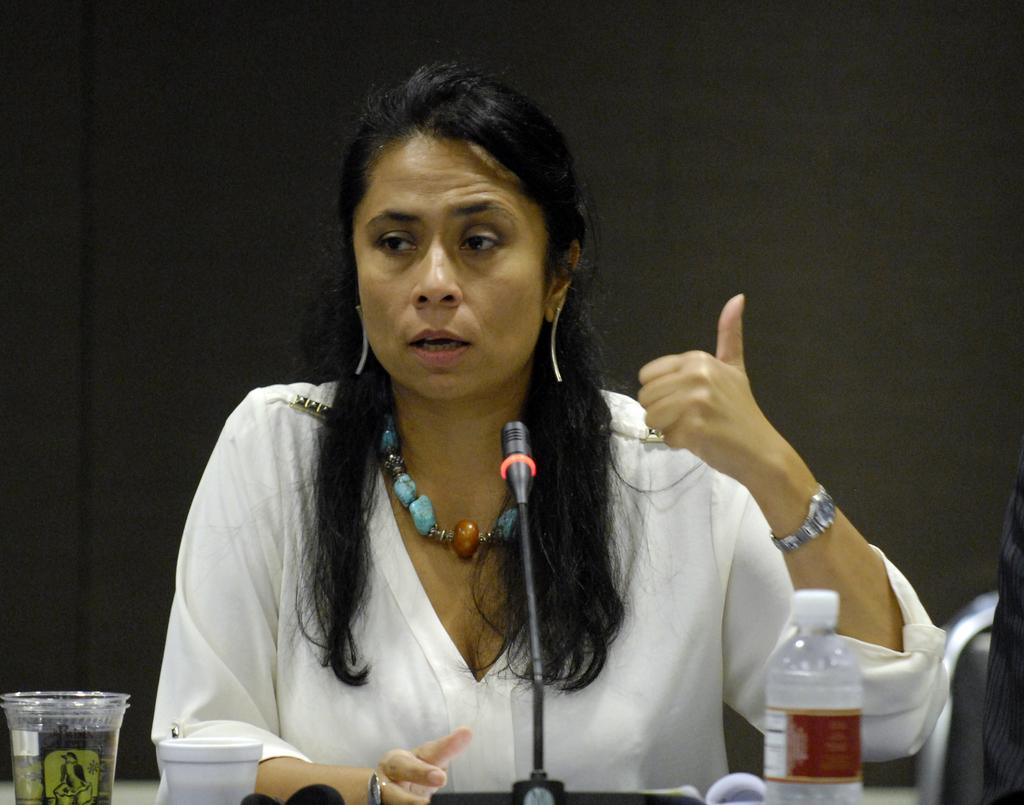Who is the main subject in the image? There is a lady in the image. What is the lady wearing? The lady is wearing a white shirt. What is the lady doing in the image? The lady is talking. What objects are in front of the lady? There is a microphone, a bottle, and glasses in front of the lady. What can be seen in the background of the image? There is a curtain in the background of the image. What type of pan can be seen in the image? There is no pan present in the image. Can you describe the fog in the image? There is no fog present in the image. 